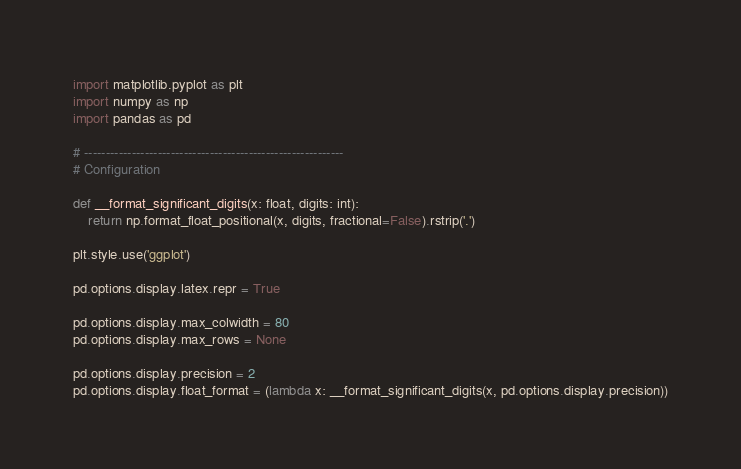<code> <loc_0><loc_0><loc_500><loc_500><_Python_>import matplotlib.pyplot as plt
import numpy as np
import pandas as pd

# ------------------------------------------------------------
# Configuration

def __format_significant_digits(x: float, digits: int):
    return np.format_float_positional(x, digits, fractional=False).rstrip('.')

plt.style.use('ggplot')

pd.options.display.latex.repr = True

pd.options.display.max_colwidth = 80
pd.options.display.max_rows = None

pd.options.display.precision = 2
pd.options.display.float_format = (lambda x: __format_significant_digits(x, pd.options.display.precision))
</code> 